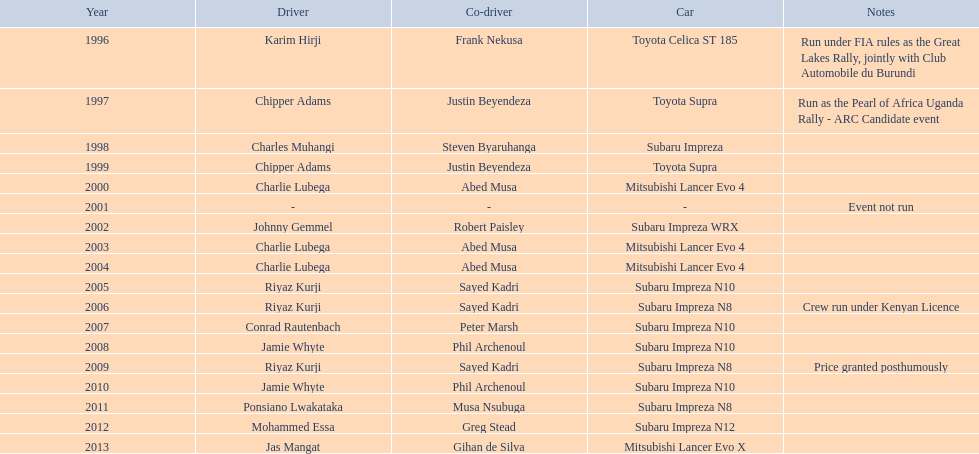How often did charlie lubega work as a driver? 3. 